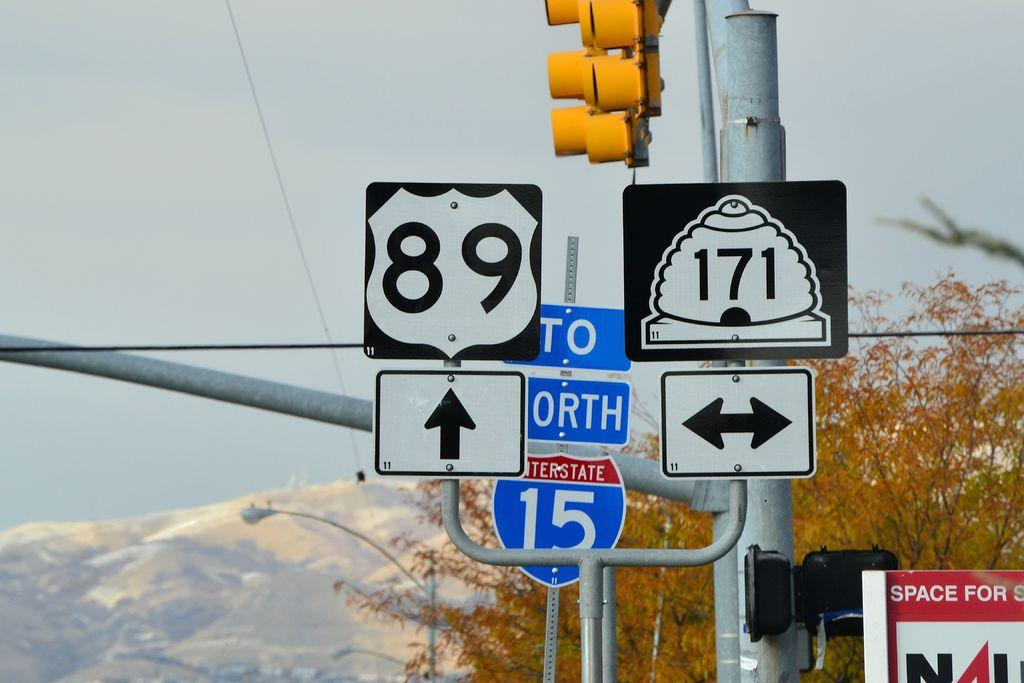<image>
Render a clear and concise summary of the photo. street signs with one showing how to get to north interstate 15 